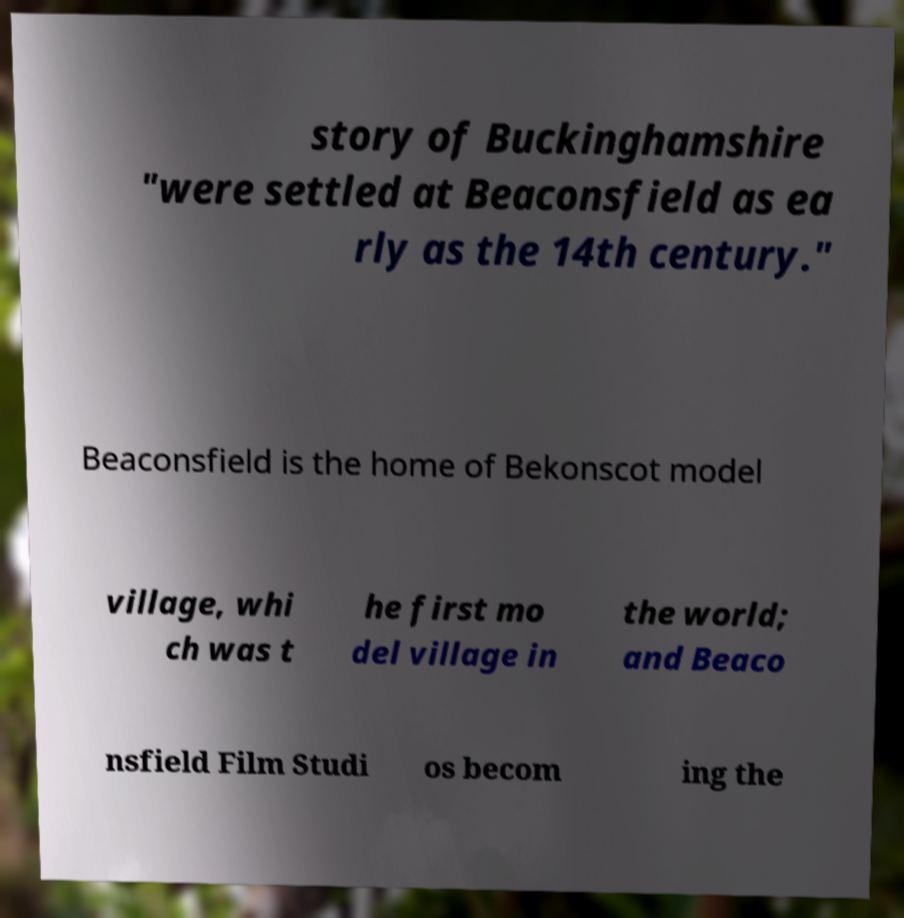For documentation purposes, I need the text within this image transcribed. Could you provide that? story of Buckinghamshire "were settled at Beaconsfield as ea rly as the 14th century." Beaconsfield is the home of Bekonscot model village, whi ch was t he first mo del village in the world; and Beaco nsfield Film Studi os becom ing the 